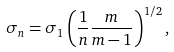Convert formula to latex. <formula><loc_0><loc_0><loc_500><loc_500>\sigma _ { n } = \sigma _ { 1 } \left ( \frac { 1 } { n } \frac { m } { m - 1 } \right ) ^ { 1 / 2 } ,</formula> 